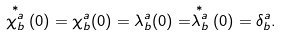<formula> <loc_0><loc_0><loc_500><loc_500>\stackrel { * } { \chi ^ { a } _ { b } } ( 0 ) = \chi ^ { a } _ { b } ( 0 ) = \lambda ^ { a } _ { b } ( 0 ) = \stackrel { * } { \lambda ^ { a } _ { b } } ( 0 ) = \delta ^ { a } _ { b } .</formula> 